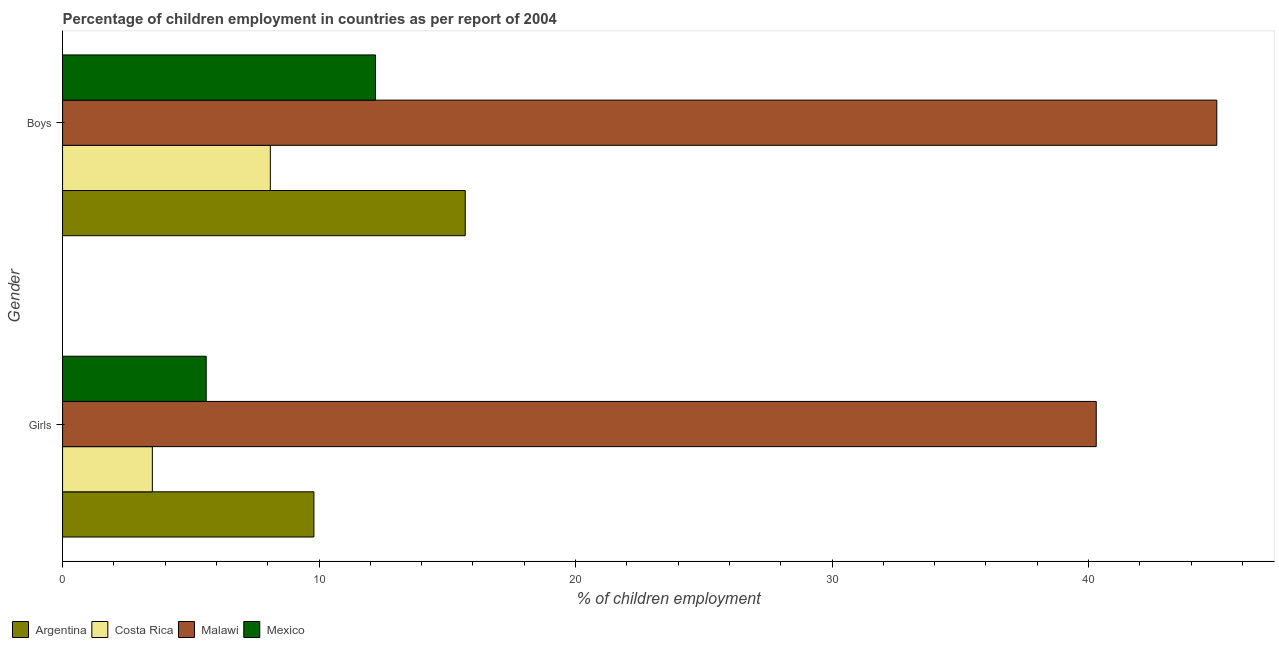How many different coloured bars are there?
Offer a very short reply. 4. Are the number of bars per tick equal to the number of legend labels?
Keep it short and to the point. Yes. How many bars are there on the 1st tick from the top?
Give a very brief answer. 4. What is the label of the 1st group of bars from the top?
Offer a terse response. Boys. What is the percentage of employed boys in Malawi?
Provide a succinct answer. 45. Across all countries, what is the maximum percentage of employed boys?
Offer a very short reply. 45. In which country was the percentage of employed boys maximum?
Offer a terse response. Malawi. What is the total percentage of employed girls in the graph?
Provide a short and direct response. 59.2. What is the difference between the percentage of employed girls in Mexico and that in Argentina?
Keep it short and to the point. -4.2. What is the average percentage of employed boys per country?
Your answer should be very brief. 20.25. What is the difference between the percentage of employed boys and percentage of employed girls in Malawi?
Ensure brevity in your answer.  4.7. In how many countries, is the percentage of employed boys greater than 30 %?
Provide a short and direct response. 1. What is the ratio of the percentage of employed girls in Malawi to that in Mexico?
Your response must be concise. 7.2. Is the percentage of employed boys in Mexico less than that in Malawi?
Keep it short and to the point. Yes. In how many countries, is the percentage of employed girls greater than the average percentage of employed girls taken over all countries?
Keep it short and to the point. 1. How many bars are there?
Your answer should be compact. 8. Are all the bars in the graph horizontal?
Make the answer very short. Yes. How many legend labels are there?
Give a very brief answer. 4. How are the legend labels stacked?
Your response must be concise. Horizontal. What is the title of the graph?
Your answer should be very brief. Percentage of children employment in countries as per report of 2004. What is the label or title of the X-axis?
Ensure brevity in your answer.  % of children employment. What is the % of children employment of Argentina in Girls?
Keep it short and to the point. 9.8. What is the % of children employment in Costa Rica in Girls?
Your answer should be compact. 3.5. What is the % of children employment in Malawi in Girls?
Keep it short and to the point. 40.3. What is the % of children employment of Mexico in Girls?
Your answer should be very brief. 5.6. What is the % of children employment in Argentina in Boys?
Provide a short and direct response. 15.7. What is the % of children employment in Malawi in Boys?
Provide a succinct answer. 45. What is the % of children employment of Mexico in Boys?
Make the answer very short. 12.2. Across all Gender, what is the maximum % of children employment in Costa Rica?
Make the answer very short. 8.1. Across all Gender, what is the maximum % of children employment of Malawi?
Provide a succinct answer. 45. Across all Gender, what is the maximum % of children employment in Mexico?
Your response must be concise. 12.2. Across all Gender, what is the minimum % of children employment in Argentina?
Your response must be concise. 9.8. Across all Gender, what is the minimum % of children employment in Costa Rica?
Your answer should be very brief. 3.5. Across all Gender, what is the minimum % of children employment of Malawi?
Your answer should be compact. 40.3. What is the total % of children employment in Malawi in the graph?
Give a very brief answer. 85.3. What is the difference between the % of children employment of Argentina in Girls and the % of children employment of Costa Rica in Boys?
Provide a short and direct response. 1.7. What is the difference between the % of children employment in Argentina in Girls and the % of children employment in Malawi in Boys?
Ensure brevity in your answer.  -35.2. What is the difference between the % of children employment of Costa Rica in Girls and the % of children employment of Malawi in Boys?
Provide a succinct answer. -41.5. What is the difference between the % of children employment in Costa Rica in Girls and the % of children employment in Mexico in Boys?
Provide a short and direct response. -8.7. What is the difference between the % of children employment in Malawi in Girls and the % of children employment in Mexico in Boys?
Your answer should be compact. 28.1. What is the average % of children employment of Argentina per Gender?
Ensure brevity in your answer.  12.75. What is the average % of children employment of Malawi per Gender?
Your answer should be compact. 42.65. What is the average % of children employment in Mexico per Gender?
Give a very brief answer. 8.9. What is the difference between the % of children employment of Argentina and % of children employment of Costa Rica in Girls?
Your answer should be compact. 6.3. What is the difference between the % of children employment in Argentina and % of children employment in Malawi in Girls?
Offer a terse response. -30.5. What is the difference between the % of children employment of Argentina and % of children employment of Mexico in Girls?
Make the answer very short. 4.2. What is the difference between the % of children employment in Costa Rica and % of children employment in Malawi in Girls?
Provide a succinct answer. -36.8. What is the difference between the % of children employment of Costa Rica and % of children employment of Mexico in Girls?
Provide a succinct answer. -2.1. What is the difference between the % of children employment in Malawi and % of children employment in Mexico in Girls?
Provide a short and direct response. 34.7. What is the difference between the % of children employment of Argentina and % of children employment of Costa Rica in Boys?
Make the answer very short. 7.6. What is the difference between the % of children employment of Argentina and % of children employment of Malawi in Boys?
Provide a short and direct response. -29.3. What is the difference between the % of children employment of Costa Rica and % of children employment of Malawi in Boys?
Your answer should be very brief. -36.9. What is the difference between the % of children employment in Costa Rica and % of children employment in Mexico in Boys?
Offer a terse response. -4.1. What is the difference between the % of children employment in Malawi and % of children employment in Mexico in Boys?
Offer a terse response. 32.8. What is the ratio of the % of children employment in Argentina in Girls to that in Boys?
Give a very brief answer. 0.62. What is the ratio of the % of children employment of Costa Rica in Girls to that in Boys?
Make the answer very short. 0.43. What is the ratio of the % of children employment in Malawi in Girls to that in Boys?
Keep it short and to the point. 0.9. What is the ratio of the % of children employment of Mexico in Girls to that in Boys?
Your response must be concise. 0.46. What is the difference between the highest and the second highest % of children employment in Costa Rica?
Provide a short and direct response. 4.6. What is the difference between the highest and the second highest % of children employment in Malawi?
Offer a very short reply. 4.7. What is the difference between the highest and the lowest % of children employment of Costa Rica?
Your answer should be compact. 4.6. What is the difference between the highest and the lowest % of children employment of Malawi?
Provide a succinct answer. 4.7. 